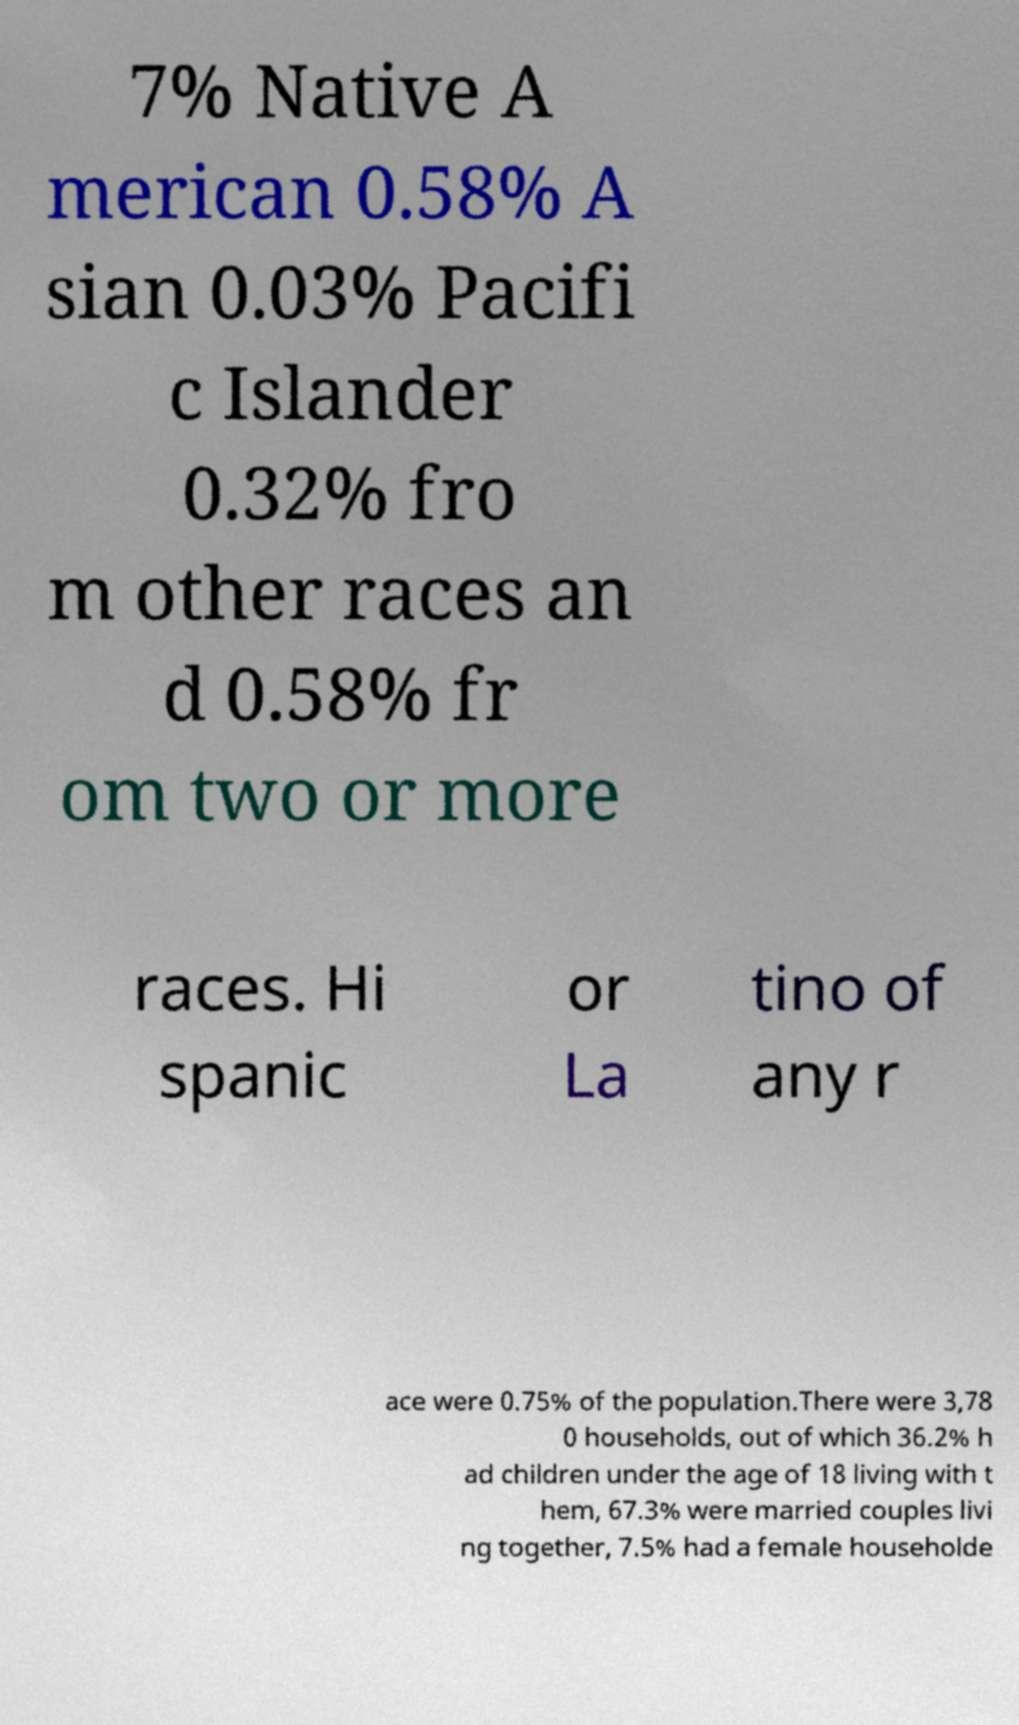There's text embedded in this image that I need extracted. Can you transcribe it verbatim? 7% Native A merican 0.58% A sian 0.03% Pacifi c Islander 0.32% fro m other races an d 0.58% fr om two or more races. Hi spanic or La tino of any r ace were 0.75% of the population.There were 3,78 0 households, out of which 36.2% h ad children under the age of 18 living with t hem, 67.3% were married couples livi ng together, 7.5% had a female householde 